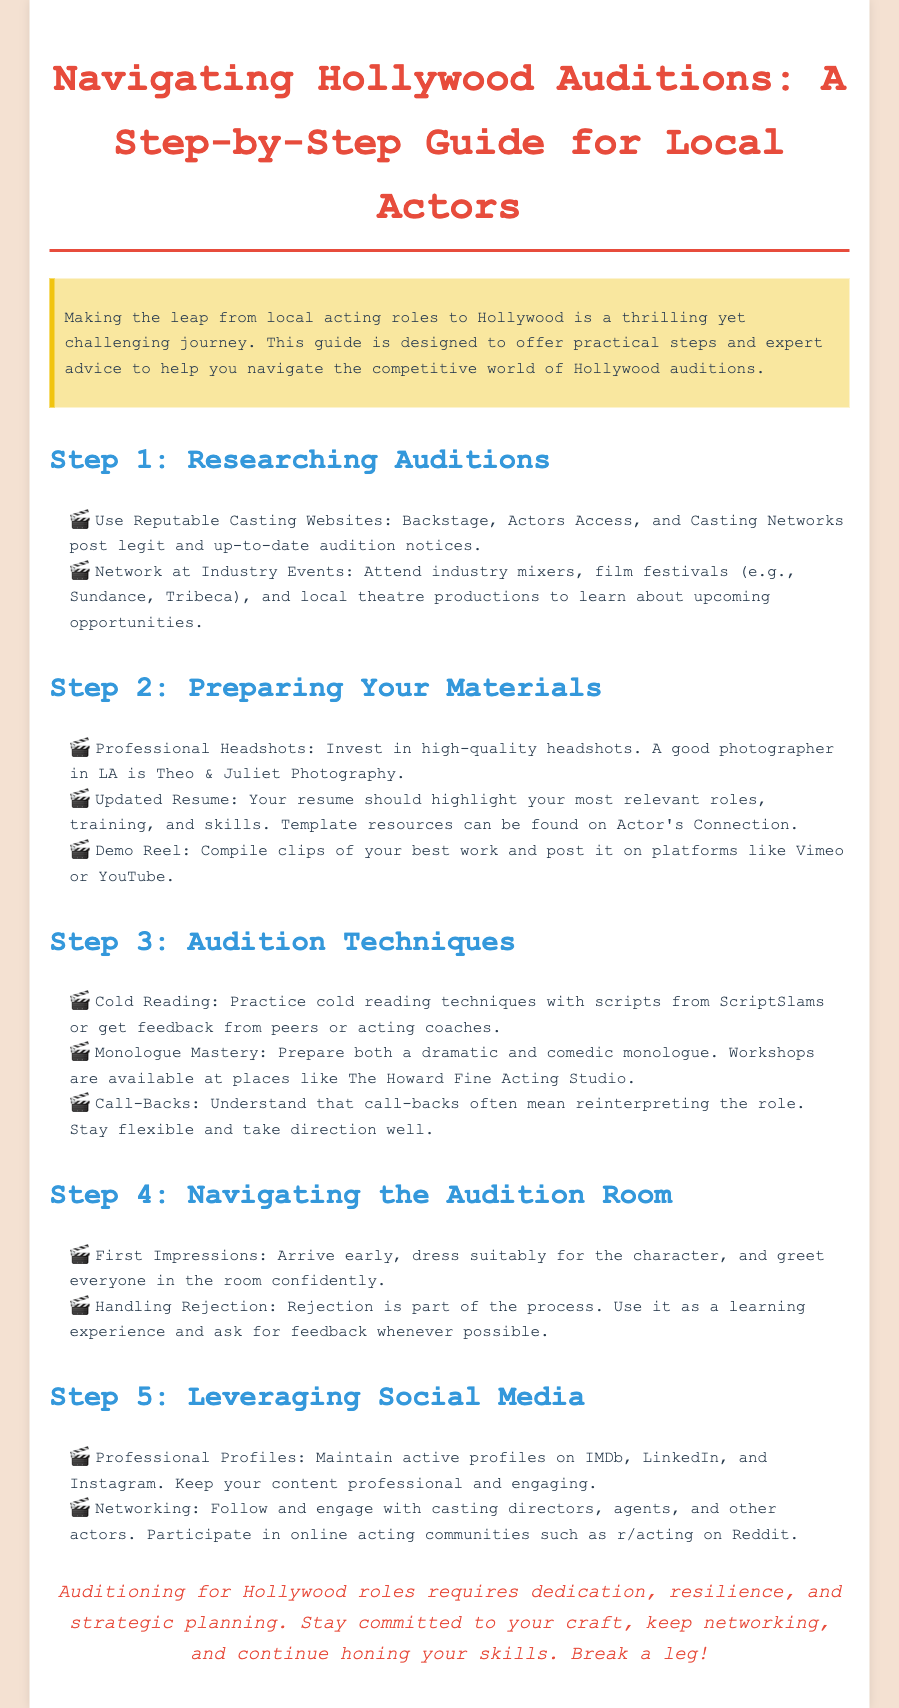What is the title of the guide? The title is the main heading of the document, which encapsulates the subject matter.
Answer: Navigating Hollywood Auditions: A Step-by-Step Guide for Local Actors What is one reputable casting website mentioned? The document lists multiple reputable websites that assist actors in finding auditions.
Answer: Backstage Who is a recommended photographer for headshots? The guide suggests a specific photographer known for high-quality headshots.
Answer: Theo & Juliet Photography What should you prepare in addition to a resume? The guide outlines necessary materials for auditions, including various types of media.
Answer: Demo Reel What is a key technique mentioned for auditions? The document provides strategies to improve audition performance that require practice.
Answer: Cold Reading Which social media platform is mentioned for maintaining professional profiles? The document highlights the importance of being active on social media for networking in the industry.
Answer: IMDb What is advised for handling rejection? The guide emphasizes the importance of a particular mindset regarding rejection in the audition process.
Answer: Learning experience What type of monologues should you prepare? The document specifies the types of monologues an actor should master for auditions.
Answer: Dramatic and comedic 